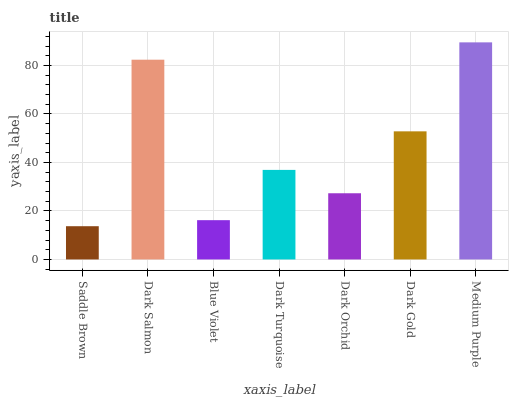Is Dark Salmon the minimum?
Answer yes or no. No. Is Dark Salmon the maximum?
Answer yes or no. No. Is Dark Salmon greater than Saddle Brown?
Answer yes or no. Yes. Is Saddle Brown less than Dark Salmon?
Answer yes or no. Yes. Is Saddle Brown greater than Dark Salmon?
Answer yes or no. No. Is Dark Salmon less than Saddle Brown?
Answer yes or no. No. Is Dark Turquoise the high median?
Answer yes or no. Yes. Is Dark Turquoise the low median?
Answer yes or no. Yes. Is Dark Orchid the high median?
Answer yes or no. No. Is Dark Gold the low median?
Answer yes or no. No. 